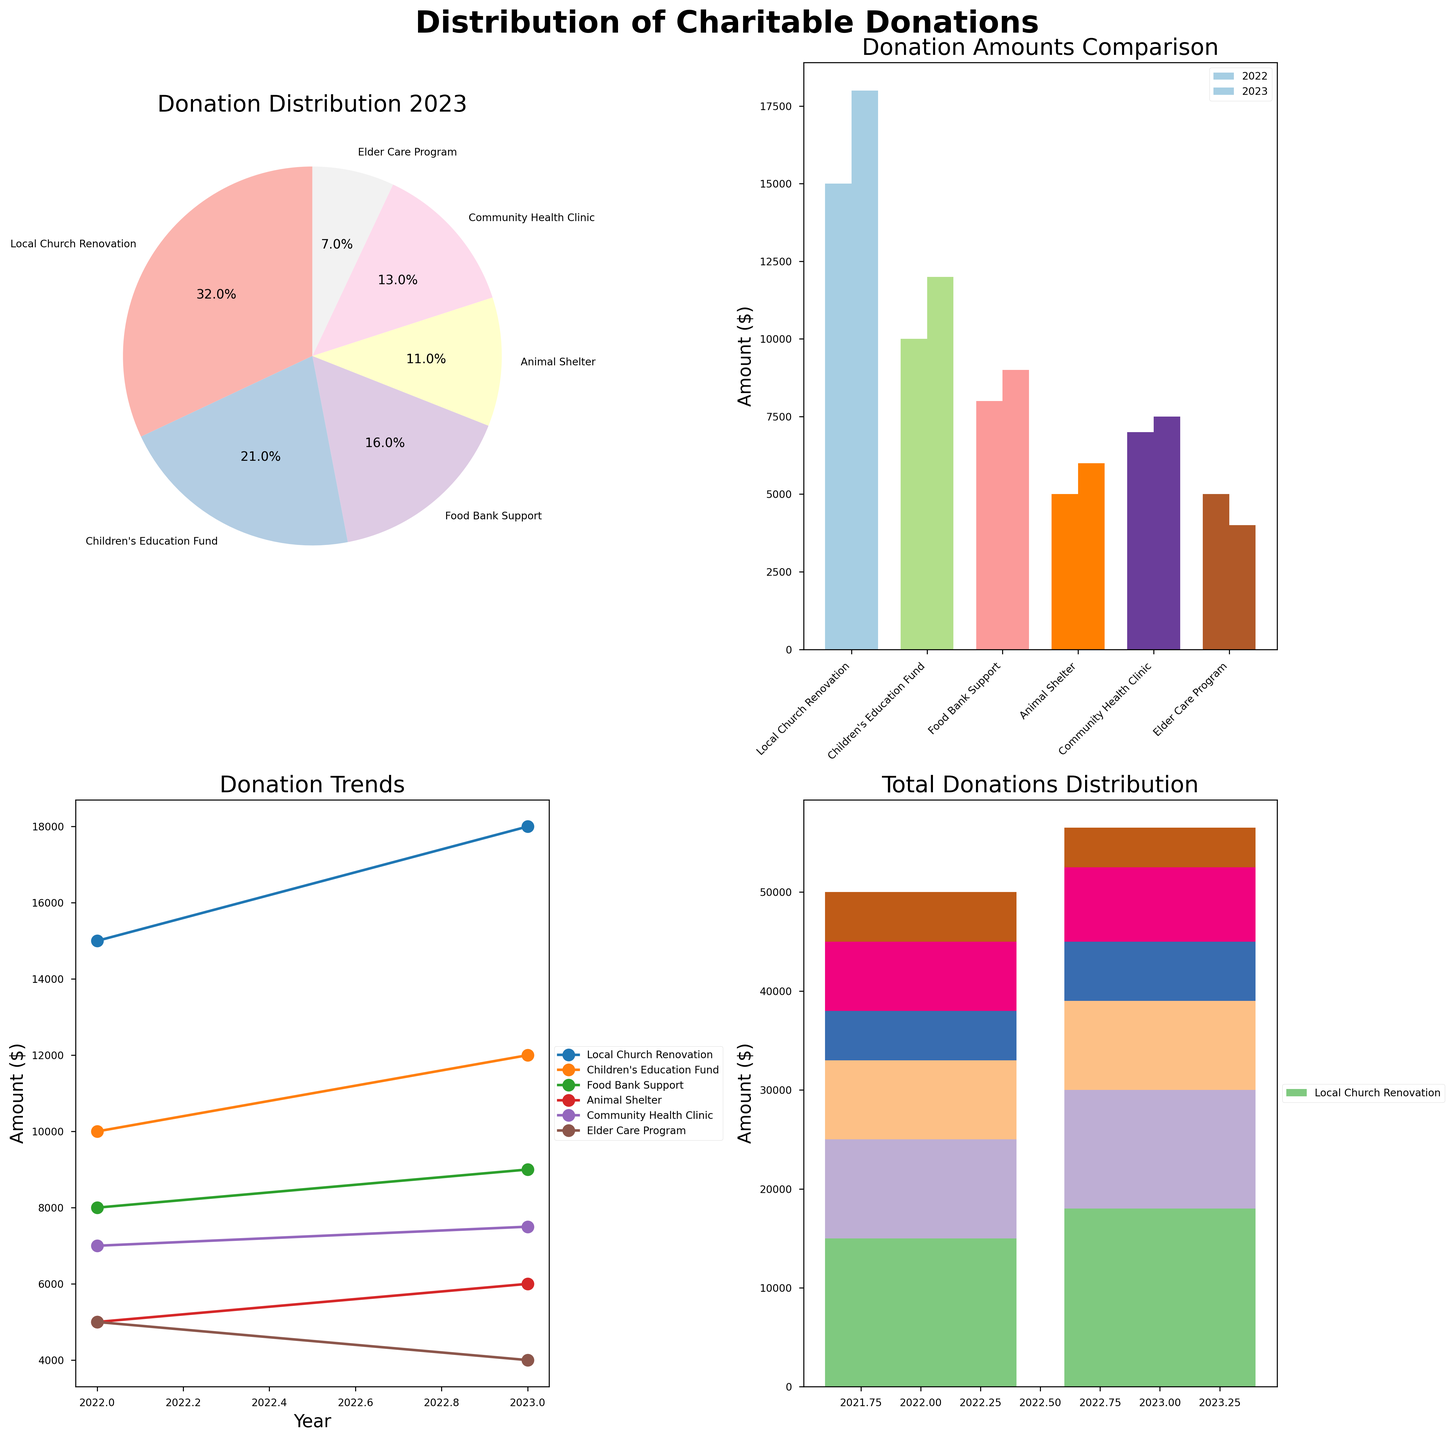what is the largest donation cause in 2023? From the pie chart titled "Donation Distribution 2023," the largest slice represents "Local Church Renovation" at 32%. This cause received the highest percentage of donations in 2023.
Answer: Local Church Renovation What is the total amount donated to the Children's Education Fund for both years combined? From the bar chart, the donation amounts for the Children's Education Fund are $10,000 in 2022 and $12,000 in 2023. Summing them up, we get $10,000 + $12,000 = $22,000.
Answer: $22,000 How do the total donation amounts compare between 2022 and 2023? To find this, we add the amounts for all causes for both years. For 2022: $15,000 + $10,000 + $8,000 + $5,000 + $7,000 + $5,000 = $50,000. For 2023: $18,000 + $12,000 + $9,000 + $6,000 + $7,500 + $4,000 = $56,500. Comparing them, $56,500 is greater than $50,000.
Answer: $56,500 in 2023 vs $50,000 in 2022 Which cause has seen an increase in donation amount from 2022 to 2023, and by how much? The bar chart shows increases for several causes. For example, "Local Church Renovation" rose from $15,000 in 2022 to $18,000 in 2023. The increase is $18,000 - $15,000 = $3,000. Other causes also have increases but this one is a significant raise.
Answer: Local Church Renovation, $3,000 Which cause had the lowest donation amount in 2023 and what was the amount? From the bar chart and the line plot, "Elder Care Program" had the lowest donation amount in 2023 with $4,000.
Answer: Elder Care Program, $4,000 How did the donations to the Food Bank Support change over the years? From the line plot, the donations to "Food Bank Support" increased from $8,000 in 2022 to $9,000 in 2023, showing a gradual trend upwards.
Answer: Increased from $8,000 to $9,000 Did any cause see a decrease in donations from 2022 to 2023? If yes, which one and by how much? From the bar chart, "Elder Care Program" shows a decrease from $5,000 in 2022 to $4,000 in 2023. The amount decreased by $1,000.
Answer: Elder Care Program, $1,000 How does the community health clinic's donation amount in 2023 compare to 2022? In 2022, the donation to "Community Health Clinic" was $7,000, and in 2023, it was $7,500, showing an increase by $500.
Answer: $500 increase 